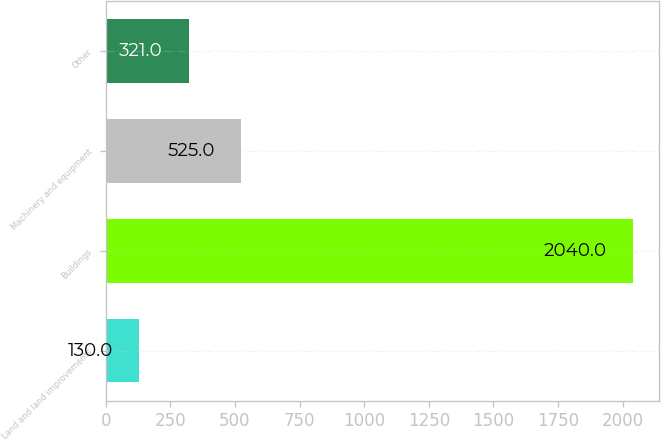<chart> <loc_0><loc_0><loc_500><loc_500><bar_chart><fcel>Land and land improvements<fcel>Buildings<fcel>Machinery and equipment<fcel>Other<nl><fcel>130<fcel>2040<fcel>525<fcel>321<nl></chart> 